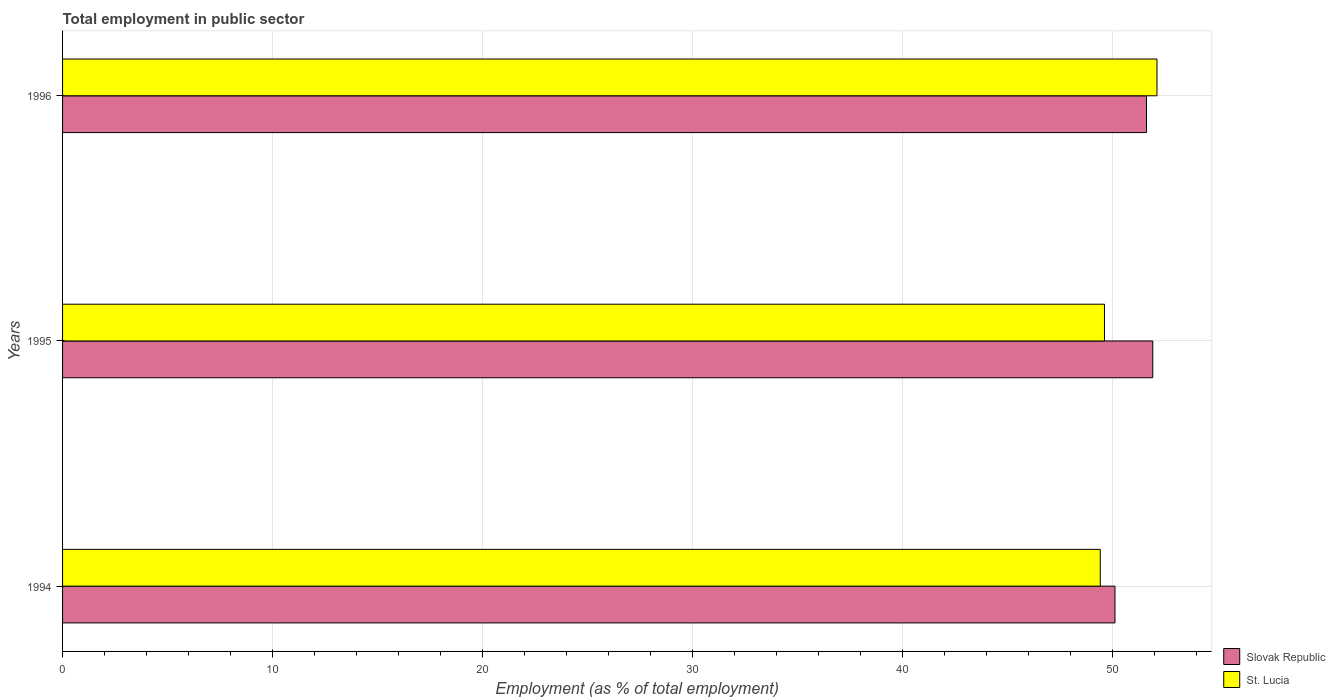Are the number of bars per tick equal to the number of legend labels?
Ensure brevity in your answer.  Yes. How many bars are there on the 3rd tick from the bottom?
Give a very brief answer. 2. What is the label of the 2nd group of bars from the top?
Your answer should be very brief. 1995. What is the employment in public sector in St. Lucia in 1994?
Your answer should be compact. 49.4. Across all years, what is the maximum employment in public sector in St. Lucia?
Your answer should be compact. 52.1. Across all years, what is the minimum employment in public sector in Slovak Republic?
Make the answer very short. 50.1. In which year was the employment in public sector in Slovak Republic maximum?
Your answer should be compact. 1995. What is the total employment in public sector in Slovak Republic in the graph?
Provide a succinct answer. 153.6. What is the difference between the employment in public sector in St. Lucia in 1995 and that in 1996?
Your response must be concise. -2.5. What is the difference between the employment in public sector in Slovak Republic in 1994 and the employment in public sector in St. Lucia in 1996?
Your answer should be very brief. -2. What is the average employment in public sector in Slovak Republic per year?
Make the answer very short. 51.2. In the year 1995, what is the difference between the employment in public sector in St. Lucia and employment in public sector in Slovak Republic?
Provide a short and direct response. -2.3. In how many years, is the employment in public sector in Slovak Republic greater than 50 %?
Your answer should be very brief. 3. What is the ratio of the employment in public sector in Slovak Republic in 1994 to that in 1996?
Give a very brief answer. 0.97. Is the employment in public sector in Slovak Republic in 1994 less than that in 1996?
Offer a terse response. Yes. What is the difference between the highest and the lowest employment in public sector in St. Lucia?
Give a very brief answer. 2.7. What does the 1st bar from the top in 1995 represents?
Provide a short and direct response. St. Lucia. What does the 2nd bar from the bottom in 1995 represents?
Ensure brevity in your answer.  St. Lucia. How many bars are there?
Keep it short and to the point. 6. How many years are there in the graph?
Make the answer very short. 3. Are the values on the major ticks of X-axis written in scientific E-notation?
Give a very brief answer. No. Does the graph contain any zero values?
Provide a succinct answer. No. How are the legend labels stacked?
Provide a succinct answer. Vertical. What is the title of the graph?
Provide a succinct answer. Total employment in public sector. Does "Luxembourg" appear as one of the legend labels in the graph?
Give a very brief answer. No. What is the label or title of the X-axis?
Give a very brief answer. Employment (as % of total employment). What is the Employment (as % of total employment) of Slovak Republic in 1994?
Your answer should be very brief. 50.1. What is the Employment (as % of total employment) of St. Lucia in 1994?
Your response must be concise. 49.4. What is the Employment (as % of total employment) in Slovak Republic in 1995?
Ensure brevity in your answer.  51.9. What is the Employment (as % of total employment) in St. Lucia in 1995?
Offer a very short reply. 49.6. What is the Employment (as % of total employment) of Slovak Republic in 1996?
Provide a short and direct response. 51.6. What is the Employment (as % of total employment) in St. Lucia in 1996?
Keep it short and to the point. 52.1. Across all years, what is the maximum Employment (as % of total employment) of Slovak Republic?
Offer a terse response. 51.9. Across all years, what is the maximum Employment (as % of total employment) of St. Lucia?
Your response must be concise. 52.1. Across all years, what is the minimum Employment (as % of total employment) of Slovak Republic?
Your answer should be compact. 50.1. Across all years, what is the minimum Employment (as % of total employment) in St. Lucia?
Your answer should be compact. 49.4. What is the total Employment (as % of total employment) of Slovak Republic in the graph?
Offer a terse response. 153.6. What is the total Employment (as % of total employment) of St. Lucia in the graph?
Offer a terse response. 151.1. What is the difference between the Employment (as % of total employment) of Slovak Republic in 1994 and that in 1996?
Offer a very short reply. -1.5. What is the difference between the Employment (as % of total employment) in Slovak Republic in 1995 and that in 1996?
Give a very brief answer. 0.3. What is the difference between the Employment (as % of total employment) of Slovak Republic in 1994 and the Employment (as % of total employment) of St. Lucia in 1996?
Ensure brevity in your answer.  -2. What is the average Employment (as % of total employment) of Slovak Republic per year?
Offer a terse response. 51.2. What is the average Employment (as % of total employment) in St. Lucia per year?
Keep it short and to the point. 50.37. In the year 1994, what is the difference between the Employment (as % of total employment) in Slovak Republic and Employment (as % of total employment) in St. Lucia?
Offer a very short reply. 0.7. In the year 1995, what is the difference between the Employment (as % of total employment) in Slovak Republic and Employment (as % of total employment) in St. Lucia?
Your answer should be very brief. 2.3. What is the ratio of the Employment (as % of total employment) of Slovak Republic in 1994 to that in 1995?
Ensure brevity in your answer.  0.97. What is the ratio of the Employment (as % of total employment) of St. Lucia in 1994 to that in 1995?
Your response must be concise. 1. What is the ratio of the Employment (as % of total employment) of Slovak Republic in 1994 to that in 1996?
Your answer should be compact. 0.97. What is the ratio of the Employment (as % of total employment) of St. Lucia in 1994 to that in 1996?
Your response must be concise. 0.95. What is the ratio of the Employment (as % of total employment) of St. Lucia in 1995 to that in 1996?
Keep it short and to the point. 0.95. What is the difference between the highest and the second highest Employment (as % of total employment) of Slovak Republic?
Your response must be concise. 0.3. What is the difference between the highest and the second highest Employment (as % of total employment) of St. Lucia?
Make the answer very short. 2.5. 